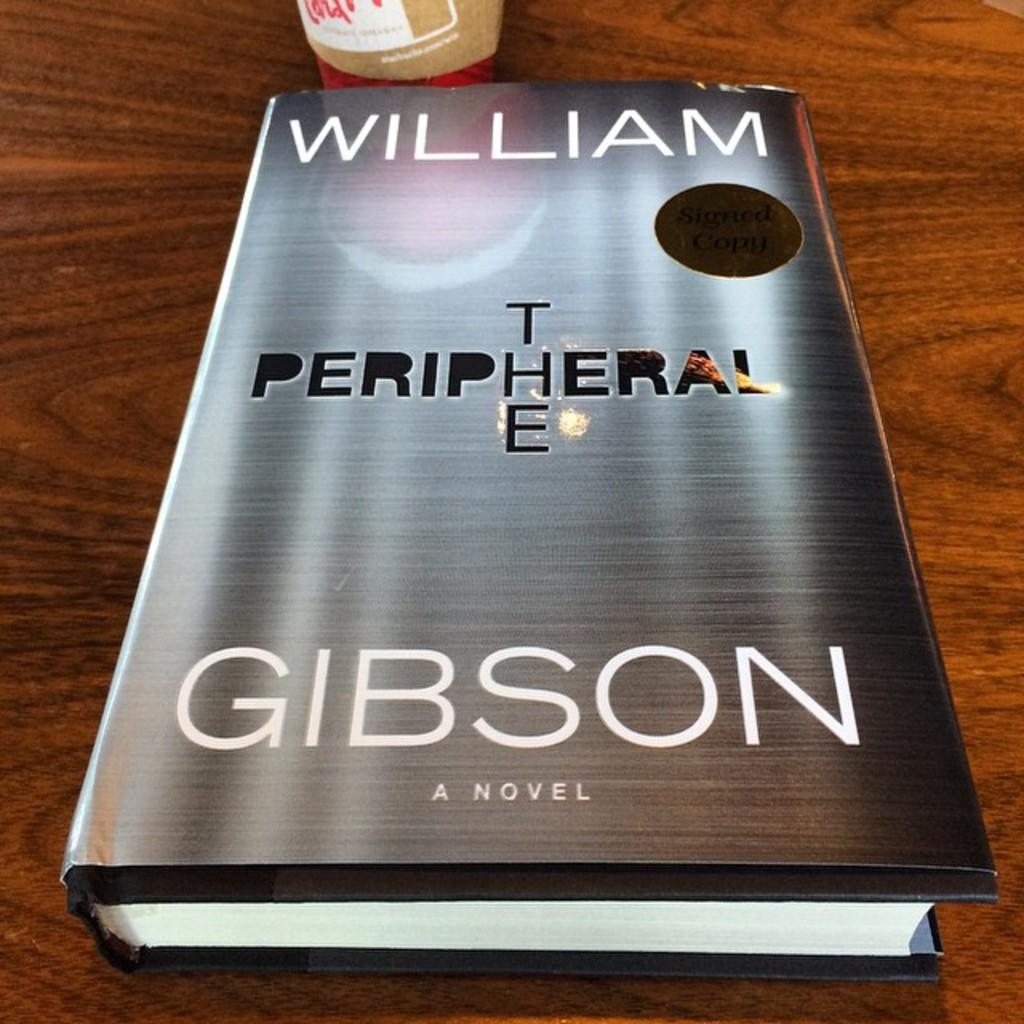Who wrote this book?
Give a very brief answer. William gibson. 